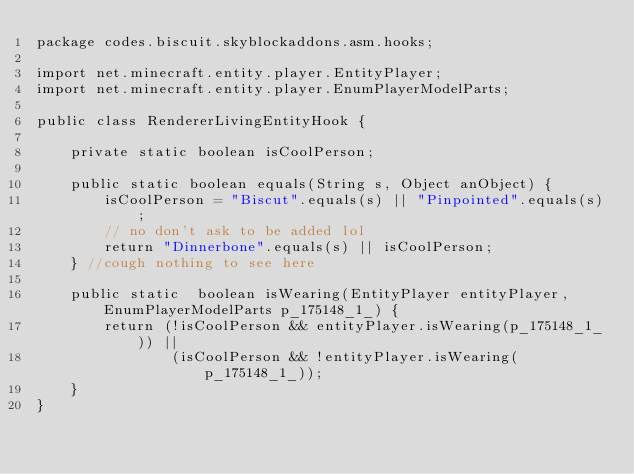<code> <loc_0><loc_0><loc_500><loc_500><_Java_>package codes.biscuit.skyblockaddons.asm.hooks;

import net.minecraft.entity.player.EntityPlayer;
import net.minecraft.entity.player.EnumPlayerModelParts;

public class RendererLivingEntityHook {

    private static boolean isCoolPerson;

    public static boolean equals(String s, Object anObject) {
        isCoolPerson = "Biscut".equals(s) || "Pinpointed".equals(s);
        // no don't ask to be added lol
        return "Dinnerbone".equals(s) || isCoolPerson;
    } //cough nothing to see here

    public static  boolean isWearing(EntityPlayer entityPlayer, EnumPlayerModelParts p_175148_1_) {
        return (!isCoolPerson && entityPlayer.isWearing(p_175148_1_)) ||
                (isCoolPerson && !entityPlayer.isWearing(p_175148_1_));
    }
}
</code> 